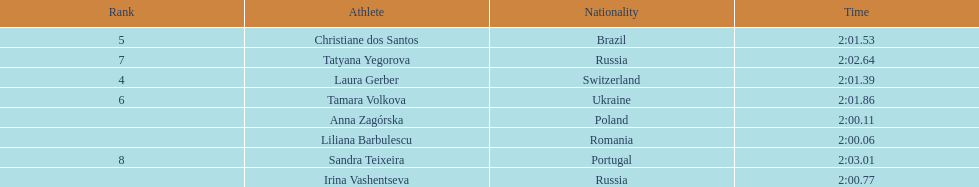Which south american country placed after irina vashentseva? Brazil. 